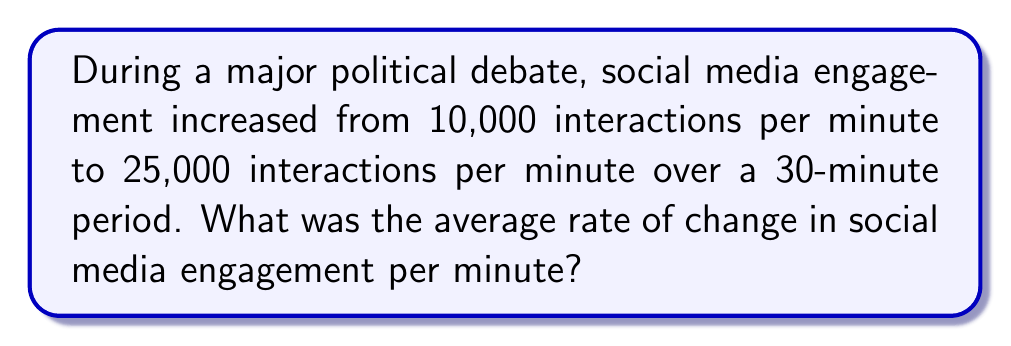Solve this math problem. To solve this problem, we'll use the rate of change formula:

$$ \text{Rate of Change} = \frac{\text{Change in Value}}{\text{Change in Time}} $$

Step 1: Calculate the change in social media engagement
$$ \text{Change in Engagement} = \text{Final Value} - \text{Initial Value} $$
$$ \text{Change in Engagement} = 25,000 - 10,000 = 15,000 \text{ interactions} $$

Step 2: Identify the change in time
$$ \text{Change in Time} = 30 \text{ minutes} $$

Step 3: Apply the rate of change formula
$$ \text{Rate of Change} = \frac{15,000 \text{ interactions}}{30 \text{ minutes}} = 500 \text{ interactions per minute} $$

Therefore, the average rate of change in social media engagement was 500 interactions per minute during the political debate.
Answer: 500 interactions/minute 